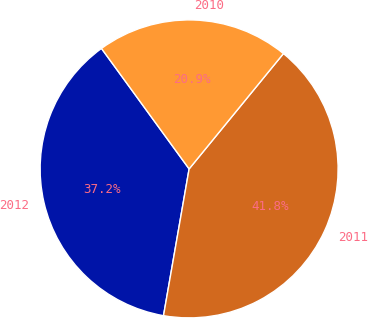<chart> <loc_0><loc_0><loc_500><loc_500><pie_chart><fcel>2012<fcel>2011<fcel>2010<nl><fcel>37.24%<fcel>41.84%<fcel>20.92%<nl></chart> 